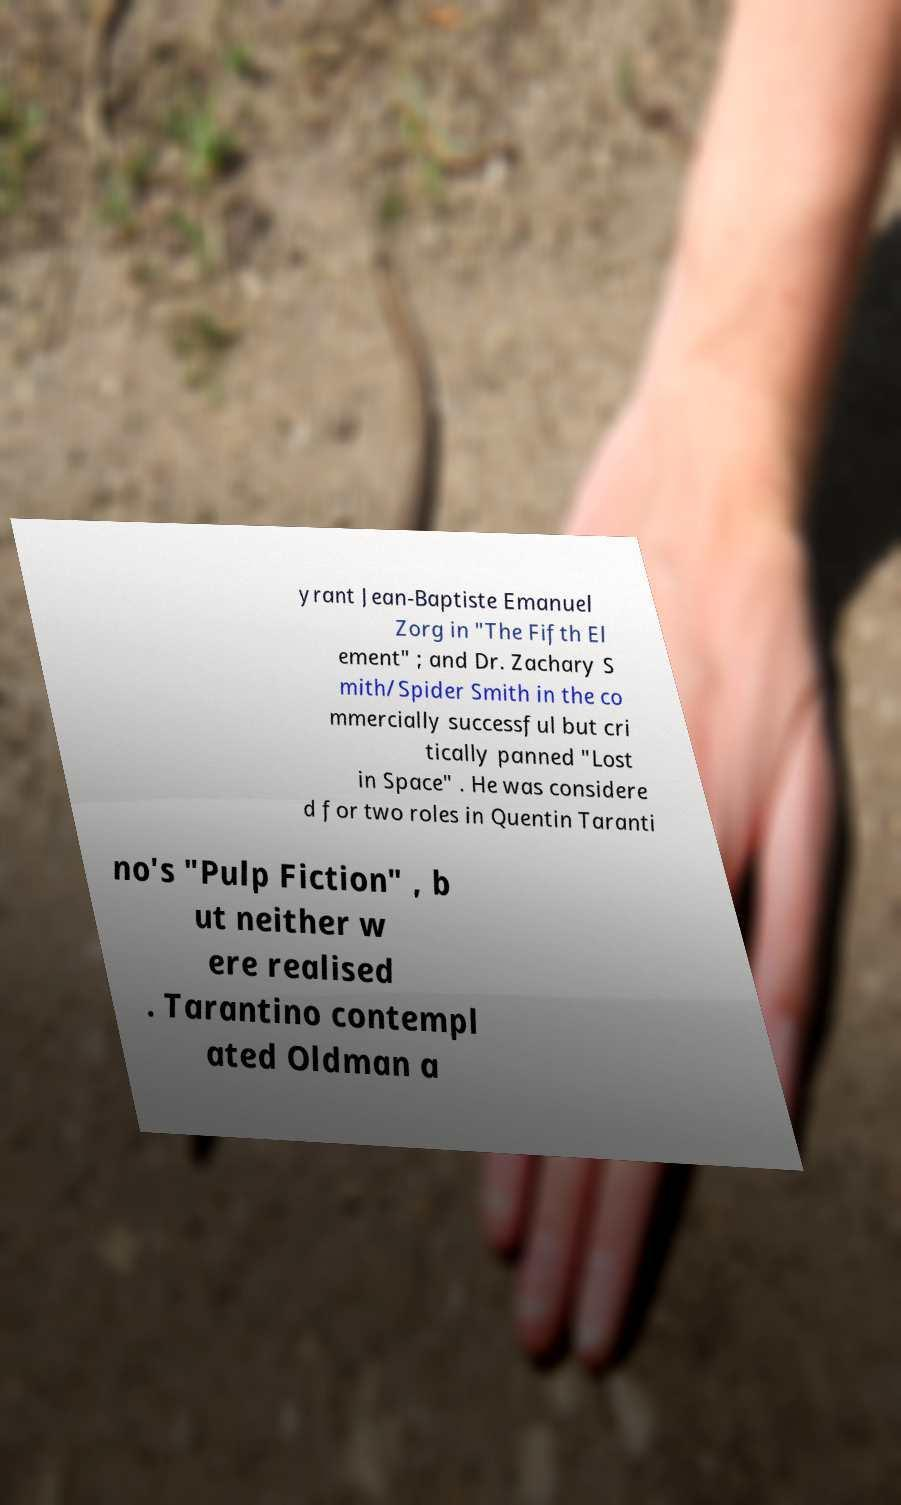I need the written content from this picture converted into text. Can you do that? yrant Jean-Baptiste Emanuel Zorg in "The Fifth El ement" ; and Dr. Zachary S mith/Spider Smith in the co mmercially successful but cri tically panned "Lost in Space" . He was considere d for two roles in Quentin Taranti no's "Pulp Fiction" , b ut neither w ere realised . Tarantino contempl ated Oldman a 